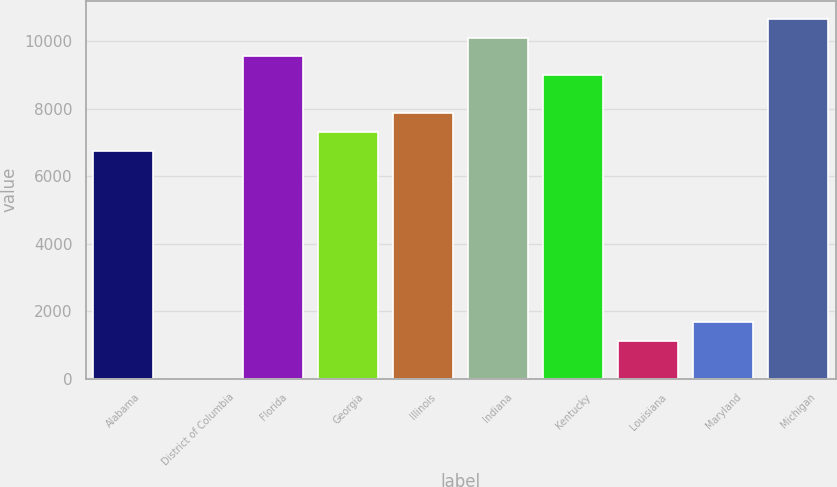<chart> <loc_0><loc_0><loc_500><loc_500><bar_chart><fcel>Alabama<fcel>District of Columbia<fcel>Florida<fcel>Georgia<fcel>Illinois<fcel>Indiana<fcel>Kentucky<fcel>Louisiana<fcel>Maryland<fcel>Michigan<nl><fcel>6740<fcel>2<fcel>9547.5<fcel>7301.5<fcel>7863<fcel>10109<fcel>8986<fcel>1125<fcel>1686.5<fcel>10670.5<nl></chart> 